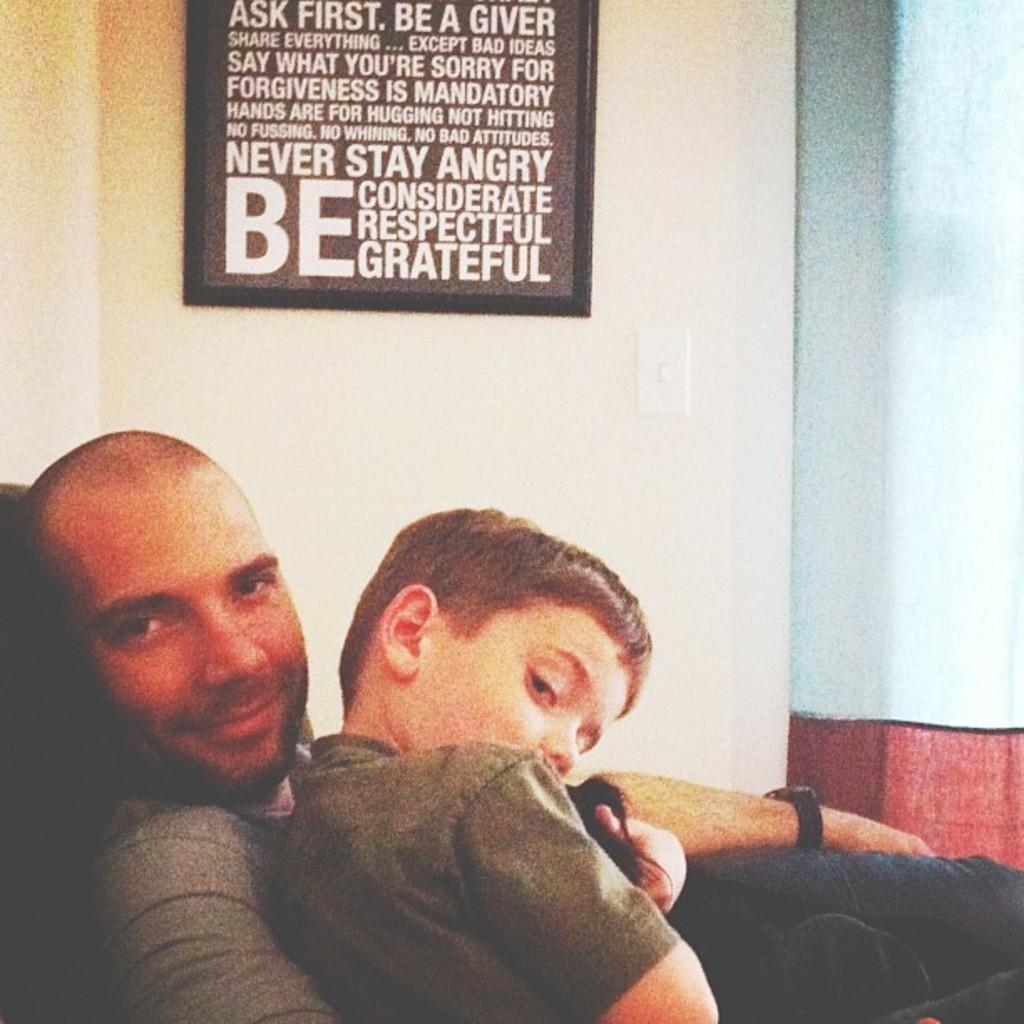In one or two sentences, can you explain what this image depicts? In this image I can see a man and a boy in the centre of this image. In the background I can see a black colour board on the wall and on it I can see something is written. 